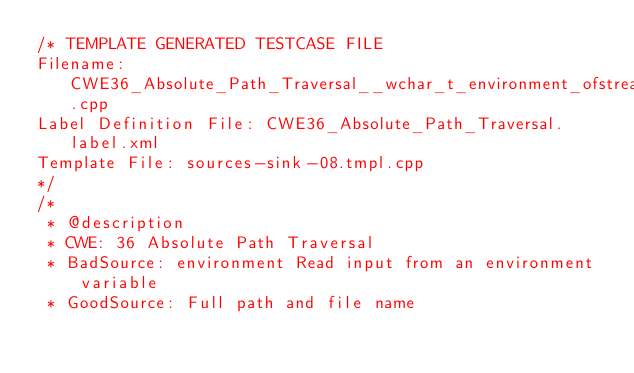Convert code to text. <code><loc_0><loc_0><loc_500><loc_500><_C++_>/* TEMPLATE GENERATED TESTCASE FILE
Filename: CWE36_Absolute_Path_Traversal__wchar_t_environment_ofstream_08.cpp
Label Definition File: CWE36_Absolute_Path_Traversal.label.xml
Template File: sources-sink-08.tmpl.cpp
*/
/*
 * @description
 * CWE: 36 Absolute Path Traversal
 * BadSource: environment Read input from an environment variable
 * GoodSource: Full path and file name</code> 